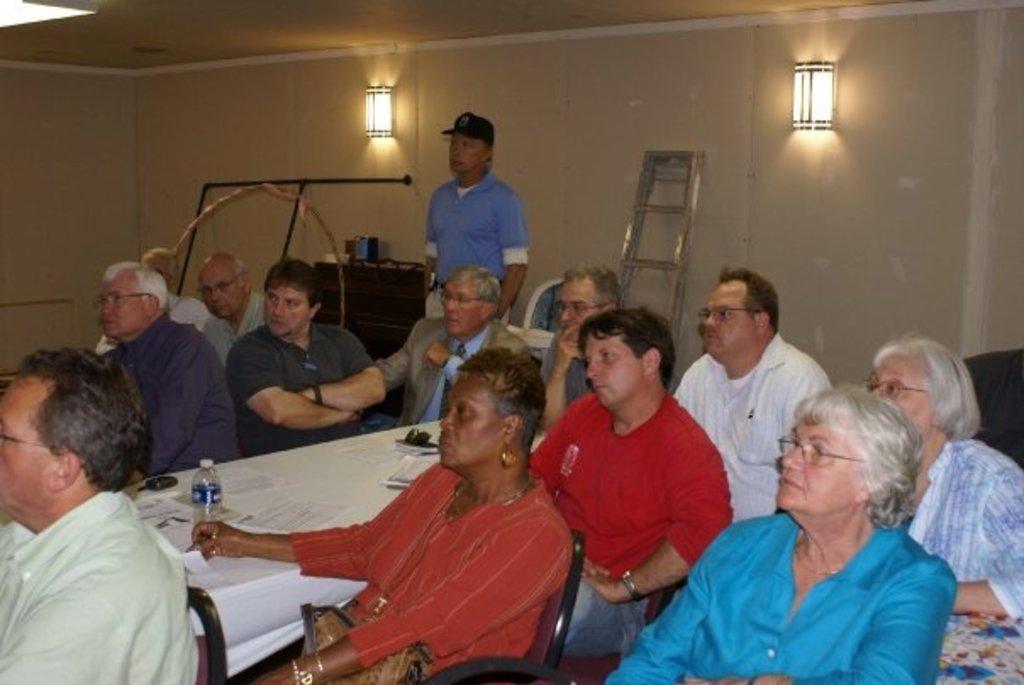Please provide a concise description of this image. In this image we can see many people sitting on chairs. Some are wearing specs. Also there is a table. On the table there is bottle, paper and some other items. Also there is a person standing and he is wearing specs. In the back there is a wall with lights. Also there is a ladder and few other objects. 